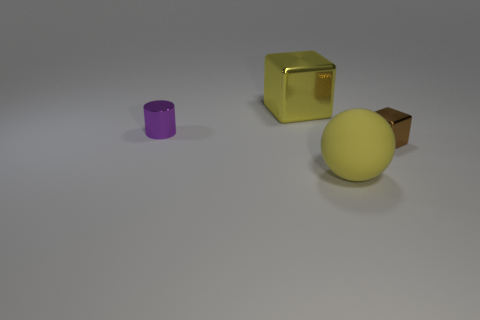Subtract 1 blocks. How many blocks are left? 1 Subtract all cylinders. How many objects are left? 3 Subtract all yellow blocks. Subtract all gray cylinders. How many blocks are left? 1 Subtract all brown cylinders. How many blue balls are left? 0 Subtract all matte spheres. Subtract all brown metal blocks. How many objects are left? 2 Add 3 big yellow metal things. How many big yellow metal things are left? 4 Add 4 large yellow matte spheres. How many large yellow matte spheres exist? 5 Add 4 purple shiny cylinders. How many objects exist? 8 Subtract 0 cyan cubes. How many objects are left? 4 